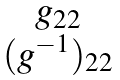<formula> <loc_0><loc_0><loc_500><loc_500>\begin{matrix} g _ { 2 2 } \\ ( g ^ { - 1 } ) _ { 2 2 } \end{matrix}</formula> 